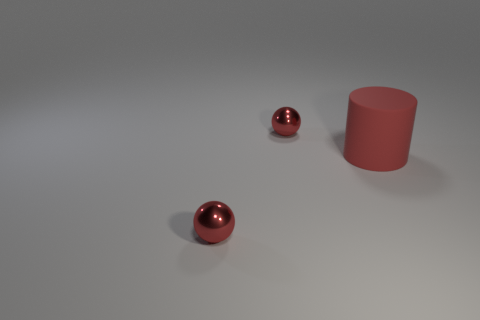Can you describe the composition of objects in this image? Certainly! The image features a simple scene composed of three objects on a flat surface. You'll notice two shiny red spheres and a larger, matte-finished red cylinder. The arrangement is somewhat scattered, with the cylinder standing upright and the spheres resting on their curves.  Which object stands out the most in this image and why? The large red cylinder stands out due to its unique shape and larger size compared to the two spheres. Its matte texture also contrasts with the reflective surface of the spheres, drawing the viewer's attention. 